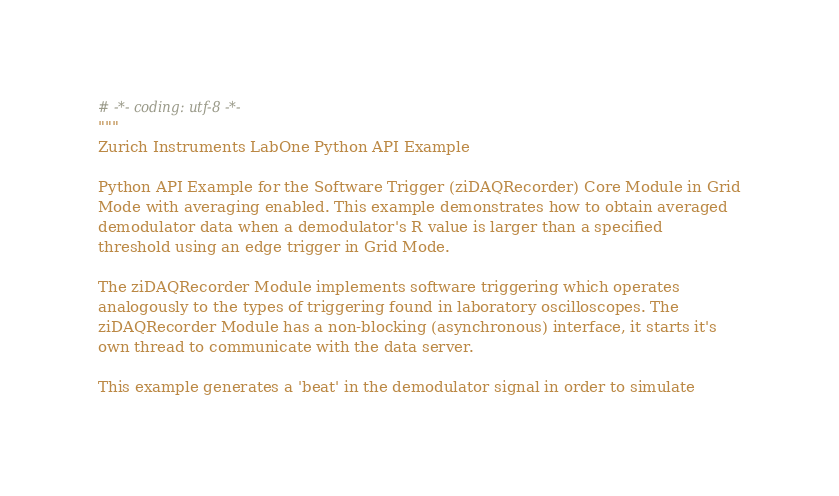<code> <loc_0><loc_0><loc_500><loc_500><_Python_># -*- coding: utf-8 -*-
"""
Zurich Instruments LabOne Python API Example

Python API Example for the Software Trigger (ziDAQRecorder) Core Module in Grid
Mode with averaging enabled. This example demonstrates how to obtain averaged
demodulator data when a demodulator's R value is larger than a specified
threshold using an edge trigger in Grid Mode.

The ziDAQRecorder Module implements software triggering which operates
analogously to the types of triggering found in laboratory oscilloscopes. The
ziDAQRecorder Module has a non-blocking (asynchronous) interface, it starts it's
own thread to communicate with the data server.

This example generates a 'beat' in the demodulator signal in order to simulate</code> 